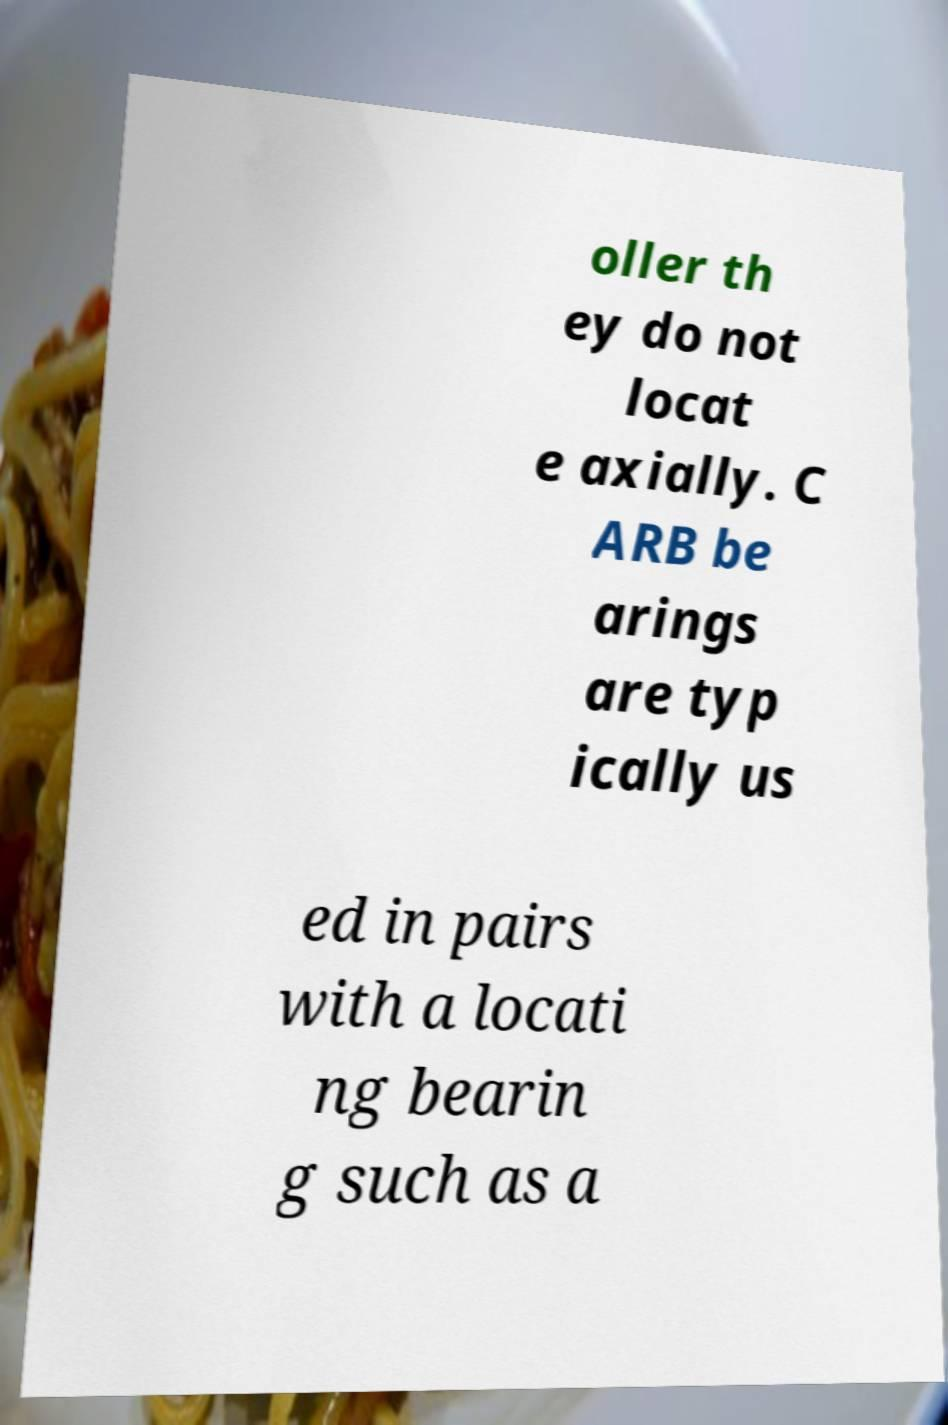Please identify and transcribe the text found in this image. oller th ey do not locat e axially. C ARB be arings are typ ically us ed in pairs with a locati ng bearin g such as a 